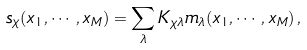Convert formula to latex. <formula><loc_0><loc_0><loc_500><loc_500>s _ { \chi } ( x _ { 1 } , \cdots , x _ { M } ) = \sum _ { \lambda } K _ { \chi \lambda } m _ { \lambda } ( x _ { 1 } , \cdots , x _ { M } ) \, ,</formula> 